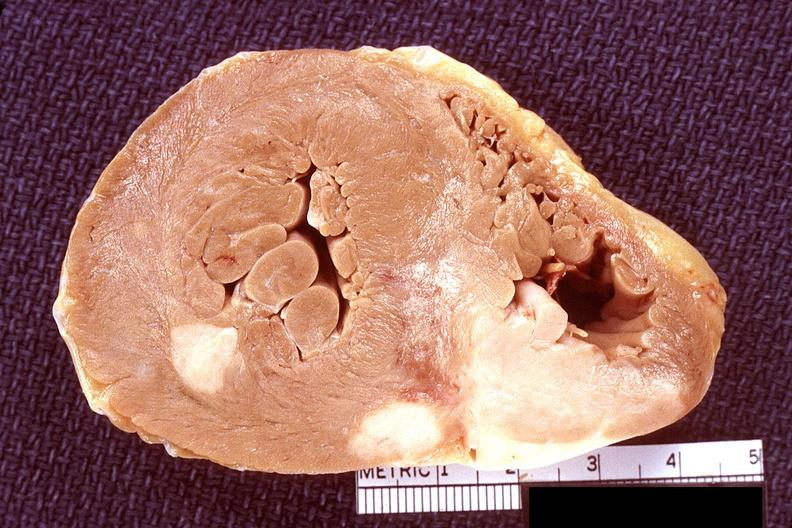s chronic ischemia present?
Answer the question using a single word or phrase. No 